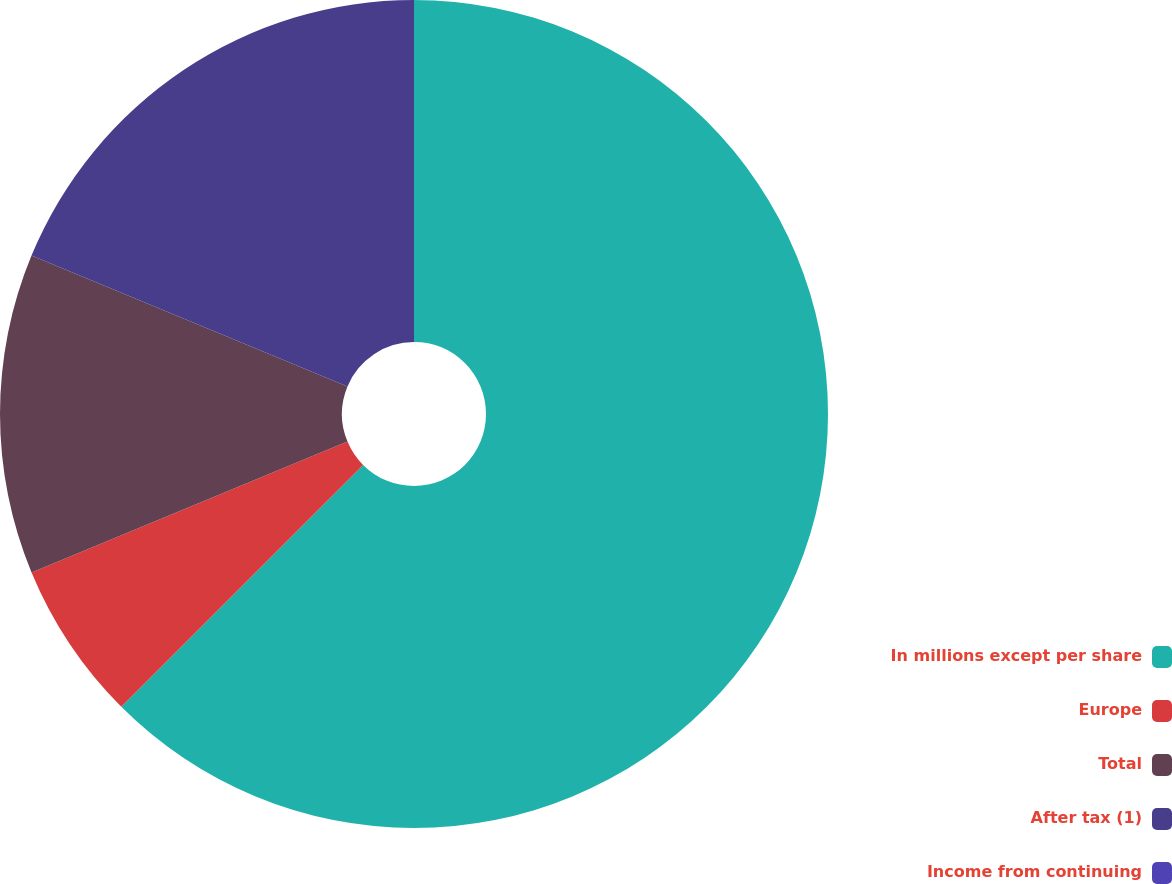Convert chart. <chart><loc_0><loc_0><loc_500><loc_500><pie_chart><fcel>In millions except per share<fcel>Europe<fcel>Total<fcel>After tax (1)<fcel>Income from continuing<nl><fcel>62.49%<fcel>6.25%<fcel>12.5%<fcel>18.75%<fcel>0.0%<nl></chart> 